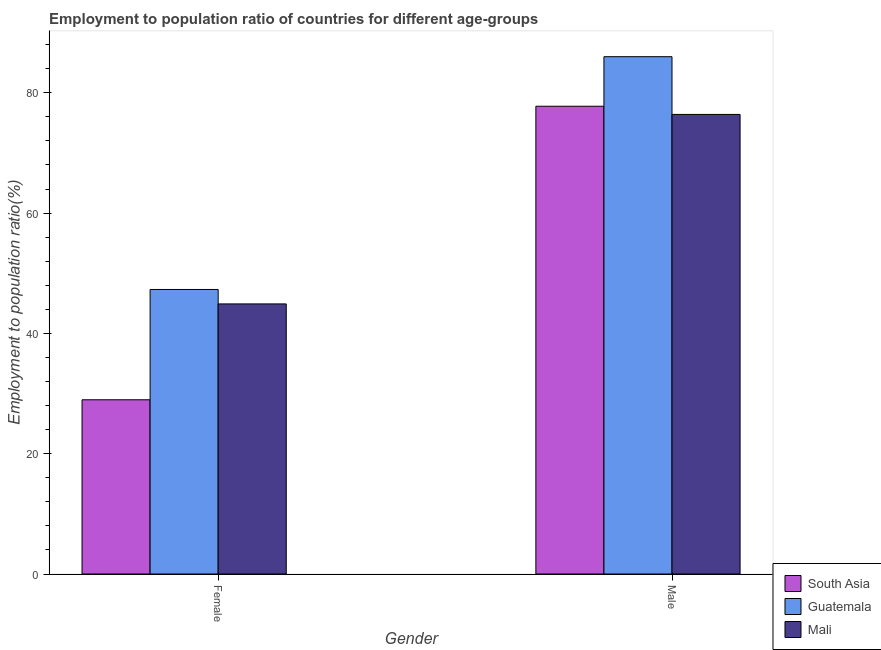Are the number of bars on each tick of the X-axis equal?
Provide a succinct answer. Yes. How many bars are there on the 1st tick from the left?
Your answer should be compact. 3. How many bars are there on the 2nd tick from the right?
Your answer should be compact. 3. What is the employment to population ratio(female) in South Asia?
Provide a short and direct response. 28.97. Across all countries, what is the maximum employment to population ratio(male)?
Ensure brevity in your answer.  86. Across all countries, what is the minimum employment to population ratio(male)?
Provide a short and direct response. 76.4. In which country was the employment to population ratio(female) maximum?
Provide a short and direct response. Guatemala. In which country was the employment to population ratio(female) minimum?
Provide a succinct answer. South Asia. What is the total employment to population ratio(male) in the graph?
Offer a very short reply. 240.16. What is the difference between the employment to population ratio(female) in Guatemala and that in Mali?
Ensure brevity in your answer.  2.4. What is the difference between the employment to population ratio(female) in South Asia and the employment to population ratio(male) in Guatemala?
Keep it short and to the point. -57.03. What is the average employment to population ratio(male) per country?
Ensure brevity in your answer.  80.05. What is the difference between the employment to population ratio(female) and employment to population ratio(male) in South Asia?
Your response must be concise. -48.8. What is the ratio of the employment to population ratio(male) in Guatemala to that in Mali?
Your response must be concise. 1.13. In how many countries, is the employment to population ratio(male) greater than the average employment to population ratio(male) taken over all countries?
Ensure brevity in your answer.  1. What does the 2nd bar from the left in Male represents?
Your answer should be very brief. Guatemala. What does the 3rd bar from the right in Female represents?
Offer a very short reply. South Asia. Are all the bars in the graph horizontal?
Offer a terse response. No. What is the difference between two consecutive major ticks on the Y-axis?
Provide a succinct answer. 20. Does the graph contain grids?
Give a very brief answer. No. Where does the legend appear in the graph?
Offer a very short reply. Bottom right. What is the title of the graph?
Offer a terse response. Employment to population ratio of countries for different age-groups. Does "East Asia (developing only)" appear as one of the legend labels in the graph?
Provide a succinct answer. No. What is the label or title of the Y-axis?
Provide a short and direct response. Employment to population ratio(%). What is the Employment to population ratio(%) in South Asia in Female?
Offer a terse response. 28.97. What is the Employment to population ratio(%) in Guatemala in Female?
Your answer should be compact. 47.3. What is the Employment to population ratio(%) of Mali in Female?
Your response must be concise. 44.9. What is the Employment to population ratio(%) of South Asia in Male?
Keep it short and to the point. 77.76. What is the Employment to population ratio(%) of Guatemala in Male?
Offer a terse response. 86. What is the Employment to population ratio(%) in Mali in Male?
Offer a very short reply. 76.4. Across all Gender, what is the maximum Employment to population ratio(%) of South Asia?
Your response must be concise. 77.76. Across all Gender, what is the maximum Employment to population ratio(%) in Guatemala?
Make the answer very short. 86. Across all Gender, what is the maximum Employment to population ratio(%) of Mali?
Offer a terse response. 76.4. Across all Gender, what is the minimum Employment to population ratio(%) of South Asia?
Your answer should be very brief. 28.97. Across all Gender, what is the minimum Employment to population ratio(%) in Guatemala?
Offer a terse response. 47.3. Across all Gender, what is the minimum Employment to population ratio(%) of Mali?
Give a very brief answer. 44.9. What is the total Employment to population ratio(%) in South Asia in the graph?
Ensure brevity in your answer.  106.73. What is the total Employment to population ratio(%) in Guatemala in the graph?
Provide a short and direct response. 133.3. What is the total Employment to population ratio(%) of Mali in the graph?
Your answer should be very brief. 121.3. What is the difference between the Employment to population ratio(%) in South Asia in Female and that in Male?
Offer a terse response. -48.8. What is the difference between the Employment to population ratio(%) in Guatemala in Female and that in Male?
Your answer should be very brief. -38.7. What is the difference between the Employment to population ratio(%) of Mali in Female and that in Male?
Offer a terse response. -31.5. What is the difference between the Employment to population ratio(%) in South Asia in Female and the Employment to population ratio(%) in Guatemala in Male?
Your answer should be compact. -57.03. What is the difference between the Employment to population ratio(%) of South Asia in Female and the Employment to population ratio(%) of Mali in Male?
Your answer should be compact. -47.44. What is the difference between the Employment to population ratio(%) of Guatemala in Female and the Employment to population ratio(%) of Mali in Male?
Give a very brief answer. -29.1. What is the average Employment to population ratio(%) of South Asia per Gender?
Provide a succinct answer. 53.36. What is the average Employment to population ratio(%) in Guatemala per Gender?
Provide a short and direct response. 66.65. What is the average Employment to population ratio(%) in Mali per Gender?
Your answer should be compact. 60.65. What is the difference between the Employment to population ratio(%) in South Asia and Employment to population ratio(%) in Guatemala in Female?
Your response must be concise. -18.33. What is the difference between the Employment to population ratio(%) of South Asia and Employment to population ratio(%) of Mali in Female?
Offer a terse response. -15.94. What is the difference between the Employment to population ratio(%) in South Asia and Employment to population ratio(%) in Guatemala in Male?
Give a very brief answer. -8.24. What is the difference between the Employment to population ratio(%) in South Asia and Employment to population ratio(%) in Mali in Male?
Offer a terse response. 1.36. What is the difference between the Employment to population ratio(%) of Guatemala and Employment to population ratio(%) of Mali in Male?
Provide a succinct answer. 9.6. What is the ratio of the Employment to population ratio(%) in South Asia in Female to that in Male?
Make the answer very short. 0.37. What is the ratio of the Employment to population ratio(%) of Guatemala in Female to that in Male?
Your response must be concise. 0.55. What is the ratio of the Employment to population ratio(%) in Mali in Female to that in Male?
Keep it short and to the point. 0.59. What is the difference between the highest and the second highest Employment to population ratio(%) in South Asia?
Give a very brief answer. 48.8. What is the difference between the highest and the second highest Employment to population ratio(%) in Guatemala?
Offer a very short reply. 38.7. What is the difference between the highest and the second highest Employment to population ratio(%) in Mali?
Provide a short and direct response. 31.5. What is the difference between the highest and the lowest Employment to population ratio(%) in South Asia?
Provide a succinct answer. 48.8. What is the difference between the highest and the lowest Employment to population ratio(%) in Guatemala?
Keep it short and to the point. 38.7. What is the difference between the highest and the lowest Employment to population ratio(%) in Mali?
Your answer should be compact. 31.5. 